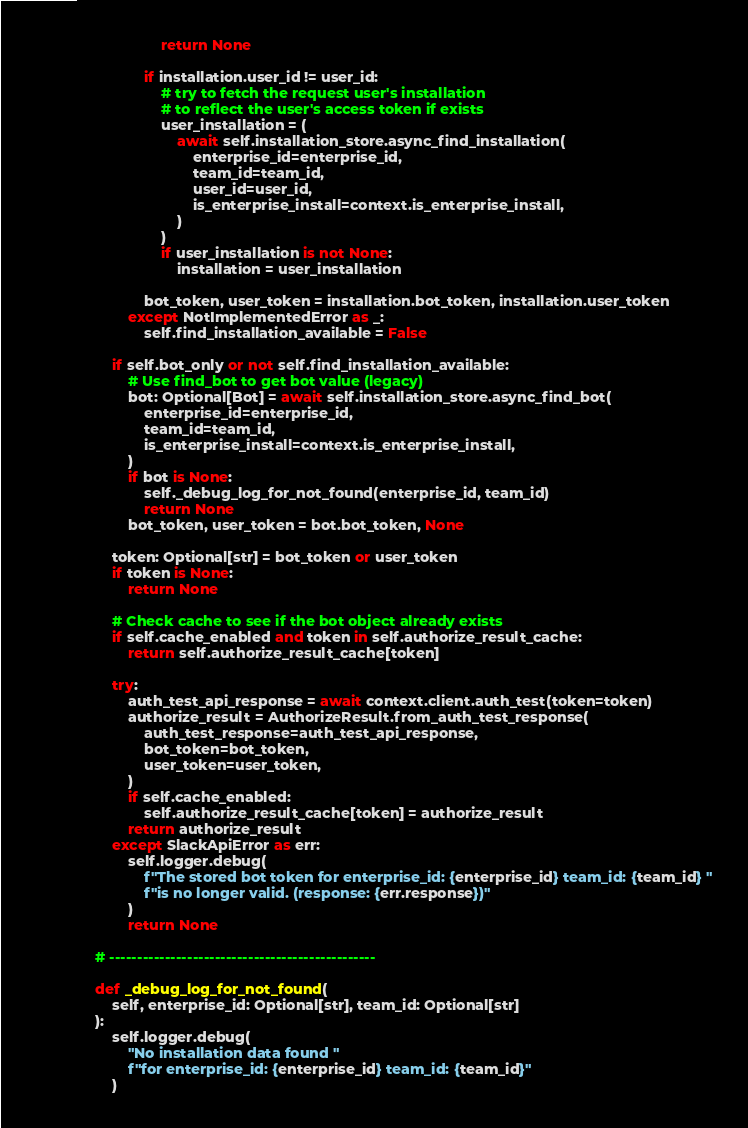<code> <loc_0><loc_0><loc_500><loc_500><_Python_>                    return None

                if installation.user_id != user_id:
                    # try to fetch the request user's installation
                    # to reflect the user's access token if exists
                    user_installation = (
                        await self.installation_store.async_find_installation(
                            enterprise_id=enterprise_id,
                            team_id=team_id,
                            user_id=user_id,
                            is_enterprise_install=context.is_enterprise_install,
                        )
                    )
                    if user_installation is not None:
                        installation = user_installation

                bot_token, user_token = installation.bot_token, installation.user_token
            except NotImplementedError as _:
                self.find_installation_available = False

        if self.bot_only or not self.find_installation_available:
            # Use find_bot to get bot value (legacy)
            bot: Optional[Bot] = await self.installation_store.async_find_bot(
                enterprise_id=enterprise_id,
                team_id=team_id,
                is_enterprise_install=context.is_enterprise_install,
            )
            if bot is None:
                self._debug_log_for_not_found(enterprise_id, team_id)
                return None
            bot_token, user_token = bot.bot_token, None

        token: Optional[str] = bot_token or user_token
        if token is None:
            return None

        # Check cache to see if the bot object already exists
        if self.cache_enabled and token in self.authorize_result_cache:
            return self.authorize_result_cache[token]

        try:
            auth_test_api_response = await context.client.auth_test(token=token)
            authorize_result = AuthorizeResult.from_auth_test_response(
                auth_test_response=auth_test_api_response,
                bot_token=bot_token,
                user_token=user_token,
            )
            if self.cache_enabled:
                self.authorize_result_cache[token] = authorize_result
            return authorize_result
        except SlackApiError as err:
            self.logger.debug(
                f"The stored bot token for enterprise_id: {enterprise_id} team_id: {team_id} "
                f"is no longer valid. (response: {err.response})"
            )
            return None

    # ------------------------------------------------

    def _debug_log_for_not_found(
        self, enterprise_id: Optional[str], team_id: Optional[str]
    ):
        self.logger.debug(
            "No installation data found "
            f"for enterprise_id: {enterprise_id} team_id: {team_id}"
        )
</code> 